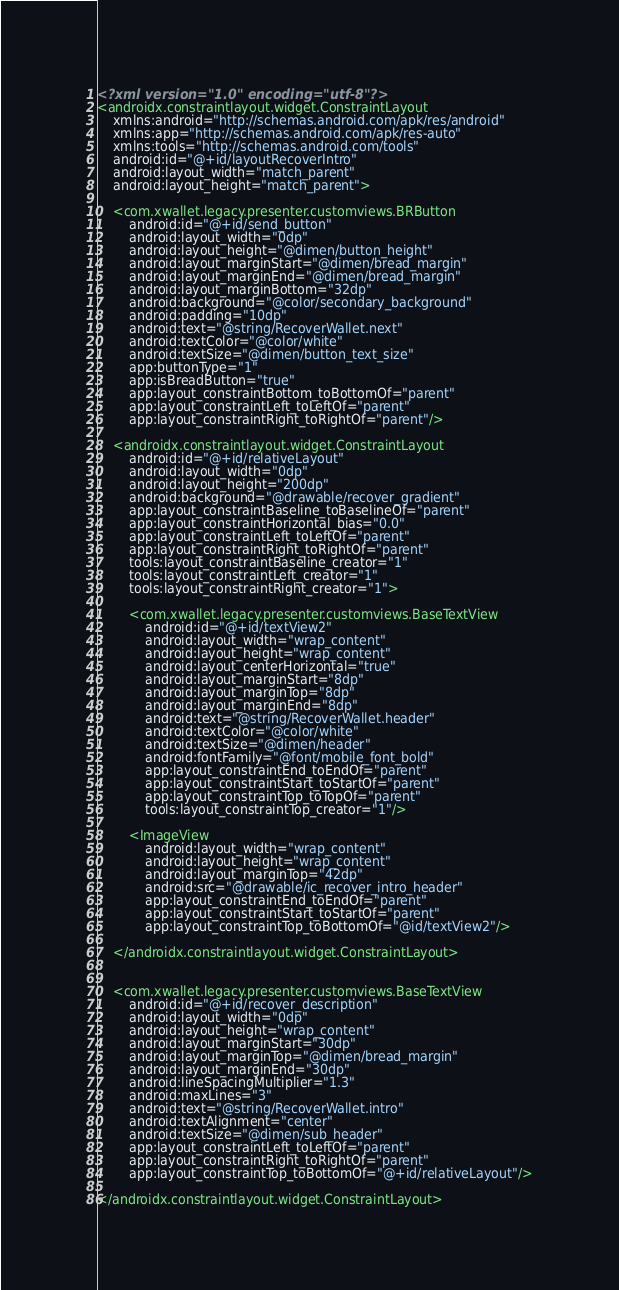<code> <loc_0><loc_0><loc_500><loc_500><_XML_><?xml version="1.0" encoding="utf-8"?>
<androidx.constraintlayout.widget.ConstraintLayout
    xmlns:android="http://schemas.android.com/apk/res/android"
    xmlns:app="http://schemas.android.com/apk/res-auto"
    xmlns:tools="http://schemas.android.com/tools"
    android:id="@+id/layoutRecoverIntro"
    android:layout_width="match_parent"
    android:layout_height="match_parent">

    <com.xwallet.legacy.presenter.customviews.BRButton
        android:id="@+id/send_button"
        android:layout_width="0dp"
        android:layout_height="@dimen/button_height"
        android:layout_marginStart="@dimen/bread_margin"
        android:layout_marginEnd="@dimen/bread_margin"
        android:layout_marginBottom="32dp"
        android:background="@color/secondary_background"
        android:padding="10dp"
        android:text="@string/RecoverWallet.next"
        android:textColor="@color/white"
        android:textSize="@dimen/button_text_size"
        app:buttonType="1"
        app:isBreadButton="true"
        app:layout_constraintBottom_toBottomOf="parent"
        app:layout_constraintLeft_toLeftOf="parent"
        app:layout_constraintRight_toRightOf="parent"/>

    <androidx.constraintlayout.widget.ConstraintLayout
        android:id="@+id/relativeLayout"
        android:layout_width="0dp"
        android:layout_height="200dp"
        android:background="@drawable/recover_gradient"
        app:layout_constraintBaseline_toBaselineOf="parent"
        app:layout_constraintHorizontal_bias="0.0"
        app:layout_constraintLeft_toLeftOf="parent"
        app:layout_constraintRight_toRightOf="parent"
        tools:layout_constraintBaseline_creator="1"
        tools:layout_constraintLeft_creator="1"
        tools:layout_constraintRight_creator="1">

        <com.xwallet.legacy.presenter.customviews.BaseTextView
            android:id="@+id/textView2"
            android:layout_width="wrap_content"
            android:layout_height="wrap_content"
            android:layout_centerHorizontal="true"
            android:layout_marginStart="8dp"
            android:layout_marginTop="8dp"
            android:layout_marginEnd="8dp"
            android:text="@string/RecoverWallet.header"
            android:textColor="@color/white"
            android:textSize="@dimen/header"
            android:fontFamily="@font/mobile_font_bold"
            app:layout_constraintEnd_toEndOf="parent"
            app:layout_constraintStart_toStartOf="parent"
            app:layout_constraintTop_toTopOf="parent"
            tools:layout_constraintTop_creator="1"/>

        <ImageView
            android:layout_width="wrap_content"
            android:layout_height="wrap_content"
            android:layout_marginTop="42dp"
            android:src="@drawable/ic_recover_intro_header"
            app:layout_constraintEnd_toEndOf="parent"
            app:layout_constraintStart_toStartOf="parent"
            app:layout_constraintTop_toBottomOf="@id/textView2"/>

    </androidx.constraintlayout.widget.ConstraintLayout>


    <com.xwallet.legacy.presenter.customviews.BaseTextView
        android:id="@+id/recover_description"
        android:layout_width="0dp"
        android:layout_height="wrap_content"
        android:layout_marginStart="30dp"
        android:layout_marginTop="@dimen/bread_margin"
        android:layout_marginEnd="30dp"
        android:lineSpacingMultiplier="1.3"
        android:maxLines="3"
        android:text="@string/RecoverWallet.intro"
        android:textAlignment="center"
        android:textSize="@dimen/sub_header"
        app:layout_constraintLeft_toLeftOf="parent"
        app:layout_constraintRight_toRightOf="parent"
        app:layout_constraintTop_toBottomOf="@+id/relativeLayout"/>

</androidx.constraintlayout.widget.ConstraintLayout>
</code> 